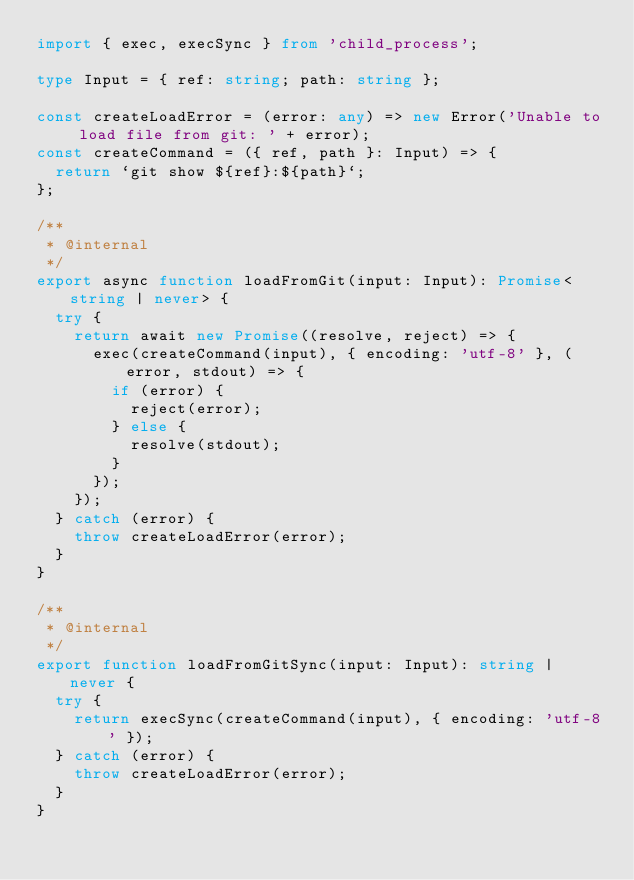<code> <loc_0><loc_0><loc_500><loc_500><_TypeScript_>import { exec, execSync } from 'child_process';

type Input = { ref: string; path: string };

const createLoadError = (error: any) => new Error('Unable to load file from git: ' + error);
const createCommand = ({ ref, path }: Input) => {
  return `git show ${ref}:${path}`;
};

/**
 * @internal
 */
export async function loadFromGit(input: Input): Promise<string | never> {
  try {
    return await new Promise((resolve, reject) => {
      exec(createCommand(input), { encoding: 'utf-8' }, (error, stdout) => {
        if (error) {
          reject(error);
        } else {
          resolve(stdout);
        }
      });
    });
  } catch (error) {
    throw createLoadError(error);
  }
}

/**
 * @internal
 */
export function loadFromGitSync(input: Input): string | never {
  try {
    return execSync(createCommand(input), { encoding: 'utf-8' });
  } catch (error) {
    throw createLoadError(error);
  }
}
</code> 